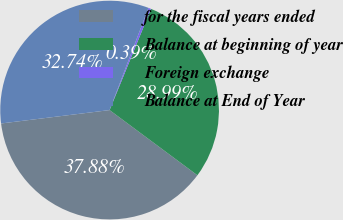<chart> <loc_0><loc_0><loc_500><loc_500><pie_chart><fcel>for the fiscal years ended<fcel>Balance at beginning of year<fcel>Foreign exchange<fcel>Balance at End of Year<nl><fcel>37.88%<fcel>28.99%<fcel>0.39%<fcel>32.74%<nl></chart> 